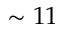Convert formula to latex. <formula><loc_0><loc_0><loc_500><loc_500>\sim 1 1</formula> 